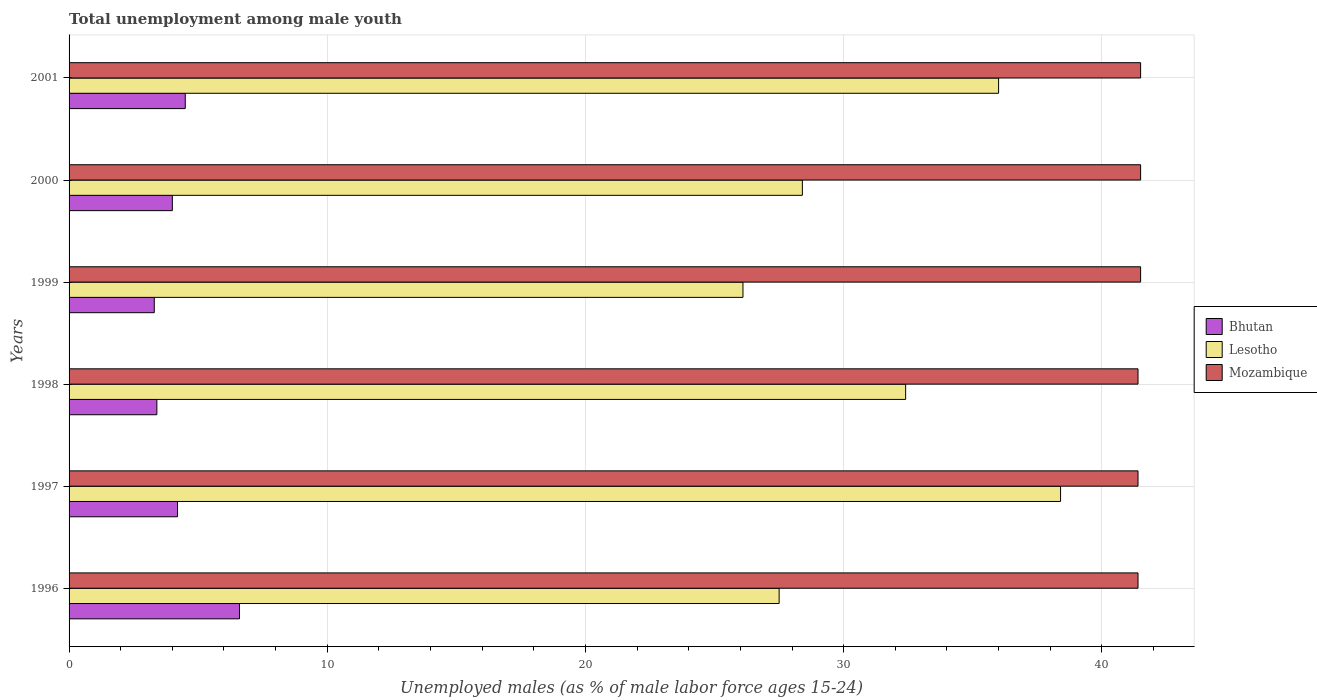What is the percentage of unemployed males in in Bhutan in 1997?
Offer a very short reply. 4.2. Across all years, what is the maximum percentage of unemployed males in in Mozambique?
Make the answer very short. 41.5. Across all years, what is the minimum percentage of unemployed males in in Mozambique?
Make the answer very short. 41.4. In which year was the percentage of unemployed males in in Mozambique maximum?
Your response must be concise. 1999. In which year was the percentage of unemployed males in in Bhutan minimum?
Offer a terse response. 1999. What is the total percentage of unemployed males in in Mozambique in the graph?
Offer a very short reply. 248.7. What is the difference between the percentage of unemployed males in in Bhutan in 1999 and that in 2000?
Ensure brevity in your answer.  -0.7. What is the difference between the percentage of unemployed males in in Mozambique in 1996 and the percentage of unemployed males in in Bhutan in 1999?
Offer a very short reply. 38.1. What is the average percentage of unemployed males in in Lesotho per year?
Make the answer very short. 31.47. In the year 1996, what is the difference between the percentage of unemployed males in in Lesotho and percentage of unemployed males in in Mozambique?
Keep it short and to the point. -13.9. What is the ratio of the percentage of unemployed males in in Bhutan in 1998 to that in 2000?
Your answer should be compact. 0.85. Is the percentage of unemployed males in in Bhutan in 1998 less than that in 2000?
Provide a succinct answer. Yes. Is the difference between the percentage of unemployed males in in Lesotho in 1996 and 1997 greater than the difference between the percentage of unemployed males in in Mozambique in 1996 and 1997?
Your response must be concise. No. What is the difference between the highest and the second highest percentage of unemployed males in in Lesotho?
Offer a terse response. 2.4. What is the difference between the highest and the lowest percentage of unemployed males in in Mozambique?
Keep it short and to the point. 0.1. In how many years, is the percentage of unemployed males in in Mozambique greater than the average percentage of unemployed males in in Mozambique taken over all years?
Keep it short and to the point. 3. Is the sum of the percentage of unemployed males in in Bhutan in 1996 and 2000 greater than the maximum percentage of unemployed males in in Lesotho across all years?
Provide a succinct answer. No. What does the 2nd bar from the top in 2000 represents?
Your answer should be compact. Lesotho. What does the 3rd bar from the bottom in 1998 represents?
Keep it short and to the point. Mozambique. Is it the case that in every year, the sum of the percentage of unemployed males in in Lesotho and percentage of unemployed males in in Mozambique is greater than the percentage of unemployed males in in Bhutan?
Ensure brevity in your answer.  Yes. Are all the bars in the graph horizontal?
Your response must be concise. Yes. Does the graph contain any zero values?
Ensure brevity in your answer.  No. Does the graph contain grids?
Offer a very short reply. Yes. How are the legend labels stacked?
Your answer should be very brief. Vertical. What is the title of the graph?
Make the answer very short. Total unemployment among male youth. What is the label or title of the X-axis?
Ensure brevity in your answer.  Unemployed males (as % of male labor force ages 15-24). What is the label or title of the Y-axis?
Offer a very short reply. Years. What is the Unemployed males (as % of male labor force ages 15-24) of Bhutan in 1996?
Your response must be concise. 6.6. What is the Unemployed males (as % of male labor force ages 15-24) in Lesotho in 1996?
Keep it short and to the point. 27.5. What is the Unemployed males (as % of male labor force ages 15-24) of Mozambique in 1996?
Provide a succinct answer. 41.4. What is the Unemployed males (as % of male labor force ages 15-24) in Bhutan in 1997?
Your answer should be very brief. 4.2. What is the Unemployed males (as % of male labor force ages 15-24) of Lesotho in 1997?
Give a very brief answer. 38.4. What is the Unemployed males (as % of male labor force ages 15-24) in Mozambique in 1997?
Keep it short and to the point. 41.4. What is the Unemployed males (as % of male labor force ages 15-24) of Bhutan in 1998?
Your answer should be compact. 3.4. What is the Unemployed males (as % of male labor force ages 15-24) of Lesotho in 1998?
Make the answer very short. 32.4. What is the Unemployed males (as % of male labor force ages 15-24) of Mozambique in 1998?
Your answer should be compact. 41.4. What is the Unemployed males (as % of male labor force ages 15-24) of Bhutan in 1999?
Ensure brevity in your answer.  3.3. What is the Unemployed males (as % of male labor force ages 15-24) of Lesotho in 1999?
Make the answer very short. 26.1. What is the Unemployed males (as % of male labor force ages 15-24) in Mozambique in 1999?
Keep it short and to the point. 41.5. What is the Unemployed males (as % of male labor force ages 15-24) in Lesotho in 2000?
Provide a short and direct response. 28.4. What is the Unemployed males (as % of male labor force ages 15-24) of Mozambique in 2000?
Keep it short and to the point. 41.5. What is the Unemployed males (as % of male labor force ages 15-24) of Bhutan in 2001?
Offer a very short reply. 4.5. What is the Unemployed males (as % of male labor force ages 15-24) in Lesotho in 2001?
Make the answer very short. 36. What is the Unemployed males (as % of male labor force ages 15-24) of Mozambique in 2001?
Keep it short and to the point. 41.5. Across all years, what is the maximum Unemployed males (as % of male labor force ages 15-24) of Bhutan?
Offer a terse response. 6.6. Across all years, what is the maximum Unemployed males (as % of male labor force ages 15-24) of Lesotho?
Provide a succinct answer. 38.4. Across all years, what is the maximum Unemployed males (as % of male labor force ages 15-24) of Mozambique?
Give a very brief answer. 41.5. Across all years, what is the minimum Unemployed males (as % of male labor force ages 15-24) in Bhutan?
Your answer should be very brief. 3.3. Across all years, what is the minimum Unemployed males (as % of male labor force ages 15-24) of Lesotho?
Provide a short and direct response. 26.1. Across all years, what is the minimum Unemployed males (as % of male labor force ages 15-24) of Mozambique?
Keep it short and to the point. 41.4. What is the total Unemployed males (as % of male labor force ages 15-24) in Lesotho in the graph?
Provide a succinct answer. 188.8. What is the total Unemployed males (as % of male labor force ages 15-24) in Mozambique in the graph?
Keep it short and to the point. 248.7. What is the difference between the Unemployed males (as % of male labor force ages 15-24) of Bhutan in 1996 and that in 1997?
Ensure brevity in your answer.  2.4. What is the difference between the Unemployed males (as % of male labor force ages 15-24) in Lesotho in 1996 and that in 1997?
Your answer should be very brief. -10.9. What is the difference between the Unemployed males (as % of male labor force ages 15-24) of Mozambique in 1996 and that in 1997?
Keep it short and to the point. 0. What is the difference between the Unemployed males (as % of male labor force ages 15-24) of Lesotho in 1996 and that in 1998?
Provide a short and direct response. -4.9. What is the difference between the Unemployed males (as % of male labor force ages 15-24) of Mozambique in 1996 and that in 1998?
Ensure brevity in your answer.  0. What is the difference between the Unemployed males (as % of male labor force ages 15-24) of Mozambique in 1996 and that in 1999?
Your answer should be compact. -0.1. What is the difference between the Unemployed males (as % of male labor force ages 15-24) of Bhutan in 1996 and that in 2000?
Offer a terse response. 2.6. What is the difference between the Unemployed males (as % of male labor force ages 15-24) in Lesotho in 1996 and that in 2000?
Provide a succinct answer. -0.9. What is the difference between the Unemployed males (as % of male labor force ages 15-24) of Mozambique in 1996 and that in 2000?
Ensure brevity in your answer.  -0.1. What is the difference between the Unemployed males (as % of male labor force ages 15-24) of Lesotho in 1996 and that in 2001?
Make the answer very short. -8.5. What is the difference between the Unemployed males (as % of male labor force ages 15-24) of Mozambique in 1996 and that in 2001?
Provide a short and direct response. -0.1. What is the difference between the Unemployed males (as % of male labor force ages 15-24) of Bhutan in 1997 and that in 1998?
Your answer should be compact. 0.8. What is the difference between the Unemployed males (as % of male labor force ages 15-24) in Lesotho in 1997 and that in 1998?
Give a very brief answer. 6. What is the difference between the Unemployed males (as % of male labor force ages 15-24) in Bhutan in 1997 and that in 1999?
Make the answer very short. 0.9. What is the difference between the Unemployed males (as % of male labor force ages 15-24) in Lesotho in 1997 and that in 1999?
Give a very brief answer. 12.3. What is the difference between the Unemployed males (as % of male labor force ages 15-24) of Mozambique in 1997 and that in 1999?
Your response must be concise. -0.1. What is the difference between the Unemployed males (as % of male labor force ages 15-24) of Mozambique in 1997 and that in 2000?
Offer a very short reply. -0.1. What is the difference between the Unemployed males (as % of male labor force ages 15-24) in Bhutan in 1997 and that in 2001?
Your answer should be very brief. -0.3. What is the difference between the Unemployed males (as % of male labor force ages 15-24) in Bhutan in 1998 and that in 1999?
Provide a succinct answer. 0.1. What is the difference between the Unemployed males (as % of male labor force ages 15-24) in Lesotho in 1998 and that in 1999?
Offer a very short reply. 6.3. What is the difference between the Unemployed males (as % of male labor force ages 15-24) of Bhutan in 1998 and that in 2000?
Provide a short and direct response. -0.6. What is the difference between the Unemployed males (as % of male labor force ages 15-24) of Lesotho in 1998 and that in 2000?
Provide a short and direct response. 4. What is the difference between the Unemployed males (as % of male labor force ages 15-24) of Mozambique in 1998 and that in 2001?
Offer a very short reply. -0.1. What is the difference between the Unemployed males (as % of male labor force ages 15-24) of Bhutan in 1999 and that in 2000?
Your answer should be compact. -0.7. What is the difference between the Unemployed males (as % of male labor force ages 15-24) of Lesotho in 1999 and that in 2000?
Provide a short and direct response. -2.3. What is the difference between the Unemployed males (as % of male labor force ages 15-24) of Lesotho in 1999 and that in 2001?
Your answer should be compact. -9.9. What is the difference between the Unemployed males (as % of male labor force ages 15-24) of Bhutan in 2000 and that in 2001?
Give a very brief answer. -0.5. What is the difference between the Unemployed males (as % of male labor force ages 15-24) of Lesotho in 2000 and that in 2001?
Make the answer very short. -7.6. What is the difference between the Unemployed males (as % of male labor force ages 15-24) in Mozambique in 2000 and that in 2001?
Keep it short and to the point. 0. What is the difference between the Unemployed males (as % of male labor force ages 15-24) in Bhutan in 1996 and the Unemployed males (as % of male labor force ages 15-24) in Lesotho in 1997?
Provide a succinct answer. -31.8. What is the difference between the Unemployed males (as % of male labor force ages 15-24) in Bhutan in 1996 and the Unemployed males (as % of male labor force ages 15-24) in Mozambique in 1997?
Give a very brief answer. -34.8. What is the difference between the Unemployed males (as % of male labor force ages 15-24) of Bhutan in 1996 and the Unemployed males (as % of male labor force ages 15-24) of Lesotho in 1998?
Your response must be concise. -25.8. What is the difference between the Unemployed males (as % of male labor force ages 15-24) of Bhutan in 1996 and the Unemployed males (as % of male labor force ages 15-24) of Mozambique in 1998?
Keep it short and to the point. -34.8. What is the difference between the Unemployed males (as % of male labor force ages 15-24) of Bhutan in 1996 and the Unemployed males (as % of male labor force ages 15-24) of Lesotho in 1999?
Give a very brief answer. -19.5. What is the difference between the Unemployed males (as % of male labor force ages 15-24) in Bhutan in 1996 and the Unemployed males (as % of male labor force ages 15-24) in Mozambique in 1999?
Your answer should be compact. -34.9. What is the difference between the Unemployed males (as % of male labor force ages 15-24) in Bhutan in 1996 and the Unemployed males (as % of male labor force ages 15-24) in Lesotho in 2000?
Your answer should be compact. -21.8. What is the difference between the Unemployed males (as % of male labor force ages 15-24) in Bhutan in 1996 and the Unemployed males (as % of male labor force ages 15-24) in Mozambique in 2000?
Offer a terse response. -34.9. What is the difference between the Unemployed males (as % of male labor force ages 15-24) of Bhutan in 1996 and the Unemployed males (as % of male labor force ages 15-24) of Lesotho in 2001?
Offer a terse response. -29.4. What is the difference between the Unemployed males (as % of male labor force ages 15-24) of Bhutan in 1996 and the Unemployed males (as % of male labor force ages 15-24) of Mozambique in 2001?
Make the answer very short. -34.9. What is the difference between the Unemployed males (as % of male labor force ages 15-24) of Bhutan in 1997 and the Unemployed males (as % of male labor force ages 15-24) of Lesotho in 1998?
Your response must be concise. -28.2. What is the difference between the Unemployed males (as % of male labor force ages 15-24) of Bhutan in 1997 and the Unemployed males (as % of male labor force ages 15-24) of Mozambique in 1998?
Give a very brief answer. -37.2. What is the difference between the Unemployed males (as % of male labor force ages 15-24) of Bhutan in 1997 and the Unemployed males (as % of male labor force ages 15-24) of Lesotho in 1999?
Provide a succinct answer. -21.9. What is the difference between the Unemployed males (as % of male labor force ages 15-24) of Bhutan in 1997 and the Unemployed males (as % of male labor force ages 15-24) of Mozambique in 1999?
Provide a succinct answer. -37.3. What is the difference between the Unemployed males (as % of male labor force ages 15-24) in Bhutan in 1997 and the Unemployed males (as % of male labor force ages 15-24) in Lesotho in 2000?
Keep it short and to the point. -24.2. What is the difference between the Unemployed males (as % of male labor force ages 15-24) in Bhutan in 1997 and the Unemployed males (as % of male labor force ages 15-24) in Mozambique in 2000?
Provide a short and direct response. -37.3. What is the difference between the Unemployed males (as % of male labor force ages 15-24) of Lesotho in 1997 and the Unemployed males (as % of male labor force ages 15-24) of Mozambique in 2000?
Give a very brief answer. -3.1. What is the difference between the Unemployed males (as % of male labor force ages 15-24) of Bhutan in 1997 and the Unemployed males (as % of male labor force ages 15-24) of Lesotho in 2001?
Offer a terse response. -31.8. What is the difference between the Unemployed males (as % of male labor force ages 15-24) of Bhutan in 1997 and the Unemployed males (as % of male labor force ages 15-24) of Mozambique in 2001?
Your response must be concise. -37.3. What is the difference between the Unemployed males (as % of male labor force ages 15-24) of Bhutan in 1998 and the Unemployed males (as % of male labor force ages 15-24) of Lesotho in 1999?
Provide a succinct answer. -22.7. What is the difference between the Unemployed males (as % of male labor force ages 15-24) of Bhutan in 1998 and the Unemployed males (as % of male labor force ages 15-24) of Mozambique in 1999?
Keep it short and to the point. -38.1. What is the difference between the Unemployed males (as % of male labor force ages 15-24) in Lesotho in 1998 and the Unemployed males (as % of male labor force ages 15-24) in Mozambique in 1999?
Your answer should be compact. -9.1. What is the difference between the Unemployed males (as % of male labor force ages 15-24) of Bhutan in 1998 and the Unemployed males (as % of male labor force ages 15-24) of Mozambique in 2000?
Ensure brevity in your answer.  -38.1. What is the difference between the Unemployed males (as % of male labor force ages 15-24) of Bhutan in 1998 and the Unemployed males (as % of male labor force ages 15-24) of Lesotho in 2001?
Provide a short and direct response. -32.6. What is the difference between the Unemployed males (as % of male labor force ages 15-24) of Bhutan in 1998 and the Unemployed males (as % of male labor force ages 15-24) of Mozambique in 2001?
Provide a short and direct response. -38.1. What is the difference between the Unemployed males (as % of male labor force ages 15-24) of Bhutan in 1999 and the Unemployed males (as % of male labor force ages 15-24) of Lesotho in 2000?
Your answer should be compact. -25.1. What is the difference between the Unemployed males (as % of male labor force ages 15-24) in Bhutan in 1999 and the Unemployed males (as % of male labor force ages 15-24) in Mozambique in 2000?
Provide a succinct answer. -38.2. What is the difference between the Unemployed males (as % of male labor force ages 15-24) of Lesotho in 1999 and the Unemployed males (as % of male labor force ages 15-24) of Mozambique in 2000?
Your answer should be compact. -15.4. What is the difference between the Unemployed males (as % of male labor force ages 15-24) of Bhutan in 1999 and the Unemployed males (as % of male labor force ages 15-24) of Lesotho in 2001?
Offer a terse response. -32.7. What is the difference between the Unemployed males (as % of male labor force ages 15-24) of Bhutan in 1999 and the Unemployed males (as % of male labor force ages 15-24) of Mozambique in 2001?
Offer a very short reply. -38.2. What is the difference between the Unemployed males (as % of male labor force ages 15-24) in Lesotho in 1999 and the Unemployed males (as % of male labor force ages 15-24) in Mozambique in 2001?
Make the answer very short. -15.4. What is the difference between the Unemployed males (as % of male labor force ages 15-24) in Bhutan in 2000 and the Unemployed males (as % of male labor force ages 15-24) in Lesotho in 2001?
Provide a succinct answer. -32. What is the difference between the Unemployed males (as % of male labor force ages 15-24) of Bhutan in 2000 and the Unemployed males (as % of male labor force ages 15-24) of Mozambique in 2001?
Provide a short and direct response. -37.5. What is the difference between the Unemployed males (as % of male labor force ages 15-24) in Lesotho in 2000 and the Unemployed males (as % of male labor force ages 15-24) in Mozambique in 2001?
Offer a terse response. -13.1. What is the average Unemployed males (as % of male labor force ages 15-24) in Bhutan per year?
Your answer should be compact. 4.33. What is the average Unemployed males (as % of male labor force ages 15-24) of Lesotho per year?
Your answer should be compact. 31.47. What is the average Unemployed males (as % of male labor force ages 15-24) of Mozambique per year?
Offer a terse response. 41.45. In the year 1996, what is the difference between the Unemployed males (as % of male labor force ages 15-24) of Bhutan and Unemployed males (as % of male labor force ages 15-24) of Lesotho?
Offer a very short reply. -20.9. In the year 1996, what is the difference between the Unemployed males (as % of male labor force ages 15-24) of Bhutan and Unemployed males (as % of male labor force ages 15-24) of Mozambique?
Ensure brevity in your answer.  -34.8. In the year 1997, what is the difference between the Unemployed males (as % of male labor force ages 15-24) in Bhutan and Unemployed males (as % of male labor force ages 15-24) in Lesotho?
Ensure brevity in your answer.  -34.2. In the year 1997, what is the difference between the Unemployed males (as % of male labor force ages 15-24) in Bhutan and Unemployed males (as % of male labor force ages 15-24) in Mozambique?
Your answer should be very brief. -37.2. In the year 1998, what is the difference between the Unemployed males (as % of male labor force ages 15-24) of Bhutan and Unemployed males (as % of male labor force ages 15-24) of Mozambique?
Your answer should be compact. -38. In the year 1998, what is the difference between the Unemployed males (as % of male labor force ages 15-24) in Lesotho and Unemployed males (as % of male labor force ages 15-24) in Mozambique?
Give a very brief answer. -9. In the year 1999, what is the difference between the Unemployed males (as % of male labor force ages 15-24) in Bhutan and Unemployed males (as % of male labor force ages 15-24) in Lesotho?
Your answer should be very brief. -22.8. In the year 1999, what is the difference between the Unemployed males (as % of male labor force ages 15-24) of Bhutan and Unemployed males (as % of male labor force ages 15-24) of Mozambique?
Offer a very short reply. -38.2. In the year 1999, what is the difference between the Unemployed males (as % of male labor force ages 15-24) of Lesotho and Unemployed males (as % of male labor force ages 15-24) of Mozambique?
Offer a very short reply. -15.4. In the year 2000, what is the difference between the Unemployed males (as % of male labor force ages 15-24) in Bhutan and Unemployed males (as % of male labor force ages 15-24) in Lesotho?
Ensure brevity in your answer.  -24.4. In the year 2000, what is the difference between the Unemployed males (as % of male labor force ages 15-24) of Bhutan and Unemployed males (as % of male labor force ages 15-24) of Mozambique?
Ensure brevity in your answer.  -37.5. In the year 2000, what is the difference between the Unemployed males (as % of male labor force ages 15-24) of Lesotho and Unemployed males (as % of male labor force ages 15-24) of Mozambique?
Your response must be concise. -13.1. In the year 2001, what is the difference between the Unemployed males (as % of male labor force ages 15-24) in Bhutan and Unemployed males (as % of male labor force ages 15-24) in Lesotho?
Keep it short and to the point. -31.5. In the year 2001, what is the difference between the Unemployed males (as % of male labor force ages 15-24) of Bhutan and Unemployed males (as % of male labor force ages 15-24) of Mozambique?
Make the answer very short. -37. What is the ratio of the Unemployed males (as % of male labor force ages 15-24) of Bhutan in 1996 to that in 1997?
Offer a very short reply. 1.57. What is the ratio of the Unemployed males (as % of male labor force ages 15-24) of Lesotho in 1996 to that in 1997?
Your answer should be compact. 0.72. What is the ratio of the Unemployed males (as % of male labor force ages 15-24) of Mozambique in 1996 to that in 1997?
Offer a very short reply. 1. What is the ratio of the Unemployed males (as % of male labor force ages 15-24) in Bhutan in 1996 to that in 1998?
Your answer should be very brief. 1.94. What is the ratio of the Unemployed males (as % of male labor force ages 15-24) of Lesotho in 1996 to that in 1998?
Offer a terse response. 0.85. What is the ratio of the Unemployed males (as % of male labor force ages 15-24) in Bhutan in 1996 to that in 1999?
Provide a short and direct response. 2. What is the ratio of the Unemployed males (as % of male labor force ages 15-24) in Lesotho in 1996 to that in 1999?
Offer a very short reply. 1.05. What is the ratio of the Unemployed males (as % of male labor force ages 15-24) of Bhutan in 1996 to that in 2000?
Offer a very short reply. 1.65. What is the ratio of the Unemployed males (as % of male labor force ages 15-24) in Lesotho in 1996 to that in 2000?
Make the answer very short. 0.97. What is the ratio of the Unemployed males (as % of male labor force ages 15-24) of Bhutan in 1996 to that in 2001?
Keep it short and to the point. 1.47. What is the ratio of the Unemployed males (as % of male labor force ages 15-24) of Lesotho in 1996 to that in 2001?
Offer a terse response. 0.76. What is the ratio of the Unemployed males (as % of male labor force ages 15-24) of Mozambique in 1996 to that in 2001?
Provide a short and direct response. 1. What is the ratio of the Unemployed males (as % of male labor force ages 15-24) of Bhutan in 1997 to that in 1998?
Offer a very short reply. 1.24. What is the ratio of the Unemployed males (as % of male labor force ages 15-24) in Lesotho in 1997 to that in 1998?
Your answer should be very brief. 1.19. What is the ratio of the Unemployed males (as % of male labor force ages 15-24) in Mozambique in 1997 to that in 1998?
Ensure brevity in your answer.  1. What is the ratio of the Unemployed males (as % of male labor force ages 15-24) in Bhutan in 1997 to that in 1999?
Make the answer very short. 1.27. What is the ratio of the Unemployed males (as % of male labor force ages 15-24) in Lesotho in 1997 to that in 1999?
Ensure brevity in your answer.  1.47. What is the ratio of the Unemployed males (as % of male labor force ages 15-24) in Lesotho in 1997 to that in 2000?
Offer a terse response. 1.35. What is the ratio of the Unemployed males (as % of male labor force ages 15-24) in Mozambique in 1997 to that in 2000?
Offer a very short reply. 1. What is the ratio of the Unemployed males (as % of male labor force ages 15-24) of Lesotho in 1997 to that in 2001?
Your response must be concise. 1.07. What is the ratio of the Unemployed males (as % of male labor force ages 15-24) of Mozambique in 1997 to that in 2001?
Your response must be concise. 1. What is the ratio of the Unemployed males (as % of male labor force ages 15-24) of Bhutan in 1998 to that in 1999?
Keep it short and to the point. 1.03. What is the ratio of the Unemployed males (as % of male labor force ages 15-24) of Lesotho in 1998 to that in 1999?
Your response must be concise. 1.24. What is the ratio of the Unemployed males (as % of male labor force ages 15-24) in Bhutan in 1998 to that in 2000?
Offer a very short reply. 0.85. What is the ratio of the Unemployed males (as % of male labor force ages 15-24) in Lesotho in 1998 to that in 2000?
Offer a terse response. 1.14. What is the ratio of the Unemployed males (as % of male labor force ages 15-24) of Mozambique in 1998 to that in 2000?
Keep it short and to the point. 1. What is the ratio of the Unemployed males (as % of male labor force ages 15-24) in Bhutan in 1998 to that in 2001?
Offer a terse response. 0.76. What is the ratio of the Unemployed males (as % of male labor force ages 15-24) of Lesotho in 1998 to that in 2001?
Give a very brief answer. 0.9. What is the ratio of the Unemployed males (as % of male labor force ages 15-24) of Mozambique in 1998 to that in 2001?
Make the answer very short. 1. What is the ratio of the Unemployed males (as % of male labor force ages 15-24) of Bhutan in 1999 to that in 2000?
Provide a succinct answer. 0.82. What is the ratio of the Unemployed males (as % of male labor force ages 15-24) in Lesotho in 1999 to that in 2000?
Keep it short and to the point. 0.92. What is the ratio of the Unemployed males (as % of male labor force ages 15-24) of Mozambique in 1999 to that in 2000?
Give a very brief answer. 1. What is the ratio of the Unemployed males (as % of male labor force ages 15-24) in Bhutan in 1999 to that in 2001?
Your answer should be compact. 0.73. What is the ratio of the Unemployed males (as % of male labor force ages 15-24) of Lesotho in 1999 to that in 2001?
Give a very brief answer. 0.72. What is the ratio of the Unemployed males (as % of male labor force ages 15-24) in Mozambique in 1999 to that in 2001?
Provide a short and direct response. 1. What is the ratio of the Unemployed males (as % of male labor force ages 15-24) in Lesotho in 2000 to that in 2001?
Make the answer very short. 0.79. What is the difference between the highest and the lowest Unemployed males (as % of male labor force ages 15-24) in Lesotho?
Your answer should be very brief. 12.3. What is the difference between the highest and the lowest Unemployed males (as % of male labor force ages 15-24) of Mozambique?
Make the answer very short. 0.1. 